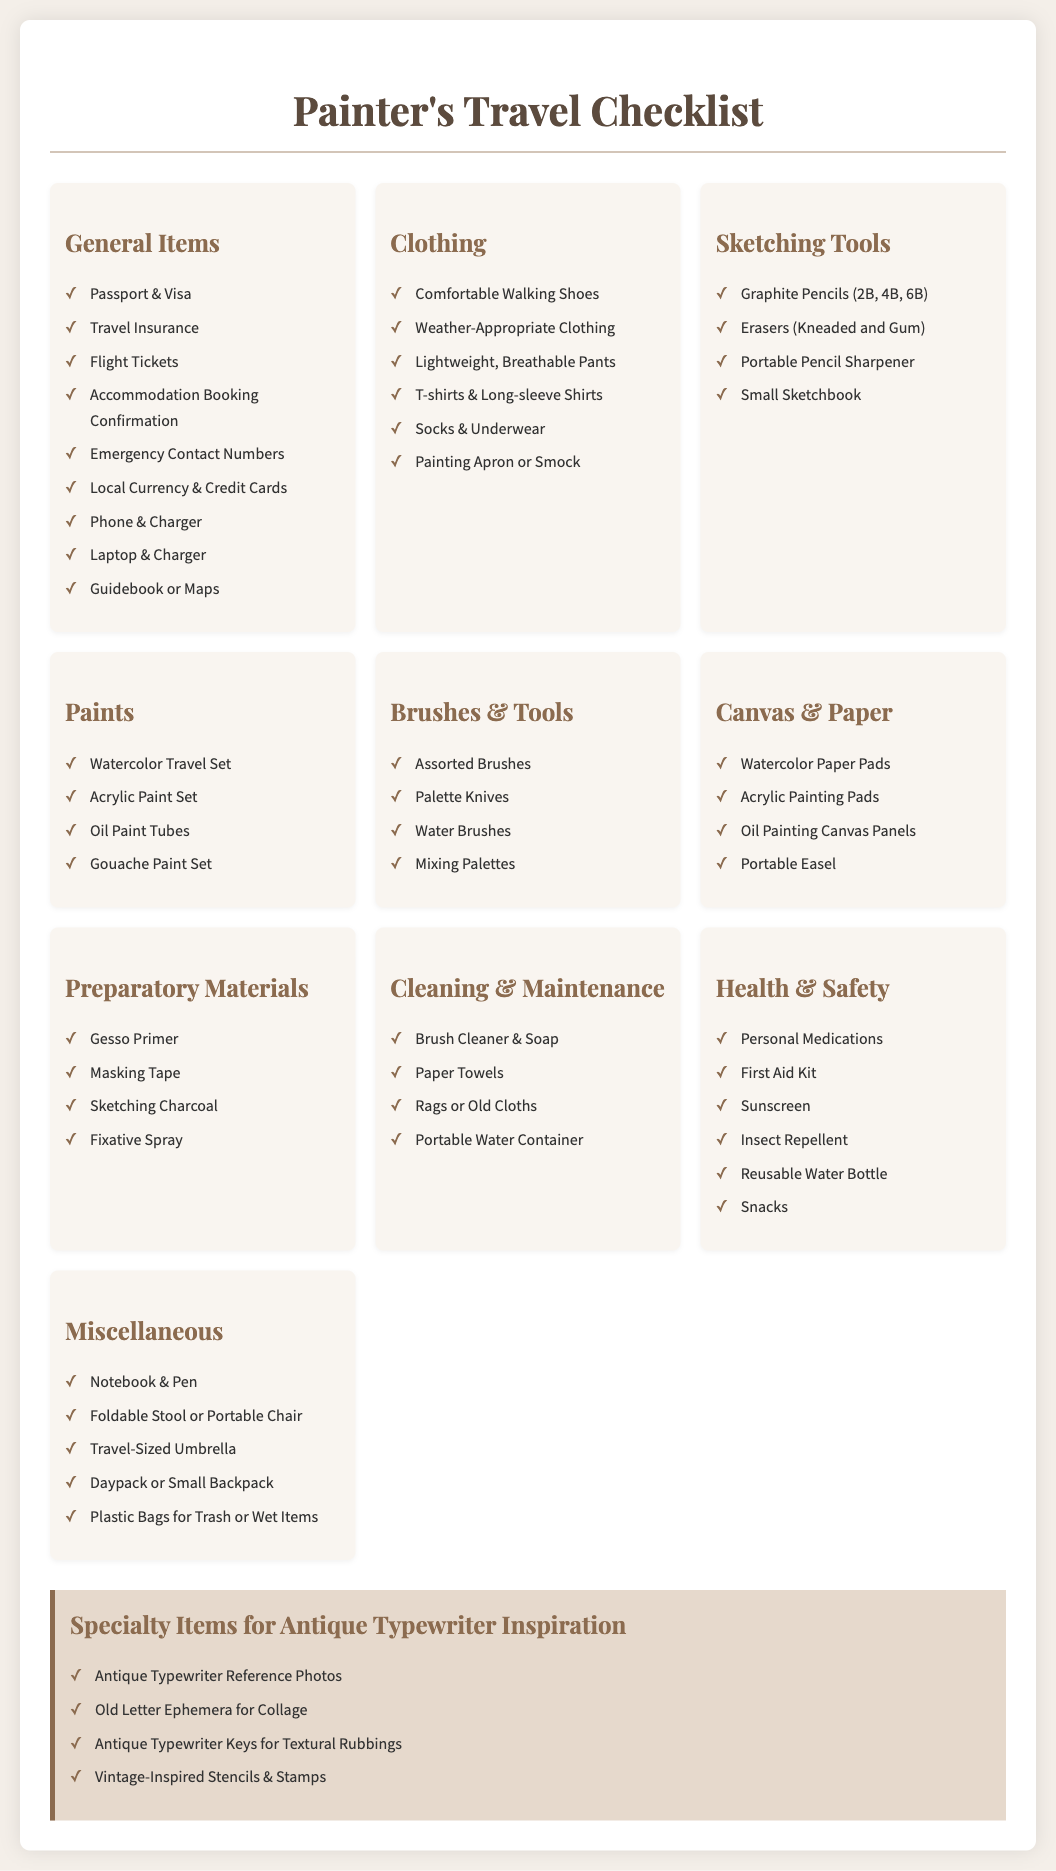What is the title of the document? The title of the document is centered at the top and states the purpose of the content.
Answer: Painter's Travel Checklist How many sections are there for general items? The general items section includes a checklist of various necessary personal travel items.
Answer: 9 What type of paints are included in the packing list? The packing list specifies different types of paints that a painter might need for their excursion.
Answer: Watercolor, Acrylic, Oil, Gouache What is a specialty item mentioned for inspiration from antique typewriters? The specialty items directly relate to the antique typewriter theme and include specific art materials for creation.
Answer: Antique Typewriter Reference Photos Which section contains health-related items? The health and safety section specifically lists items that are essential for maintaining health during travel.
Answer: Health & Safety How many items are in the cleaning & maintenance section? The cleaning and maintenance section provides a specific number of necessary supplies for upkeep during painting trips.
Answer: 4 What is a suggested item for miscellaneous needs during travel? The miscellaneous section includes practical tools or items a painter might need that do not fall under the other categories.
Answer: Notebook & Pen What type of shoes should be brought for comfort? The clothing section highlights the importance of suitable footwear for traveling and painting.
Answer: Comfortable Walking Shoes How many different kinds of brushes are listed? The brushes section provides an overview of essential tools needed for painting that a traveler should pack.
Answer: Assorted Brushes 